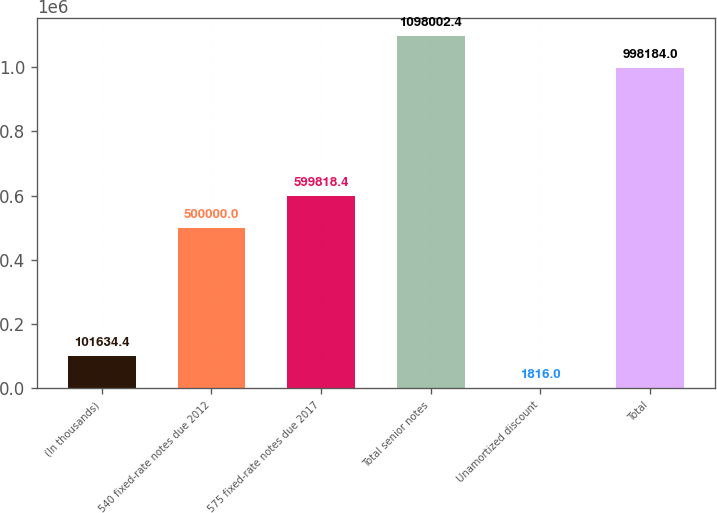<chart> <loc_0><loc_0><loc_500><loc_500><bar_chart><fcel>(In thousands)<fcel>540 fixed-rate notes due 2012<fcel>575 fixed-rate notes due 2017<fcel>Total senior notes<fcel>Unamortized discount<fcel>Total<nl><fcel>101634<fcel>500000<fcel>599818<fcel>1.098e+06<fcel>1816<fcel>998184<nl></chart> 